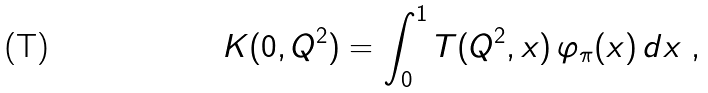<formula> <loc_0><loc_0><loc_500><loc_500>K ( 0 , Q ^ { 2 } ) = \int _ { 0 } ^ { 1 } T ( Q ^ { 2 } , x ) \, \varphi _ { \pi } ( x ) \, d x \ ,</formula> 